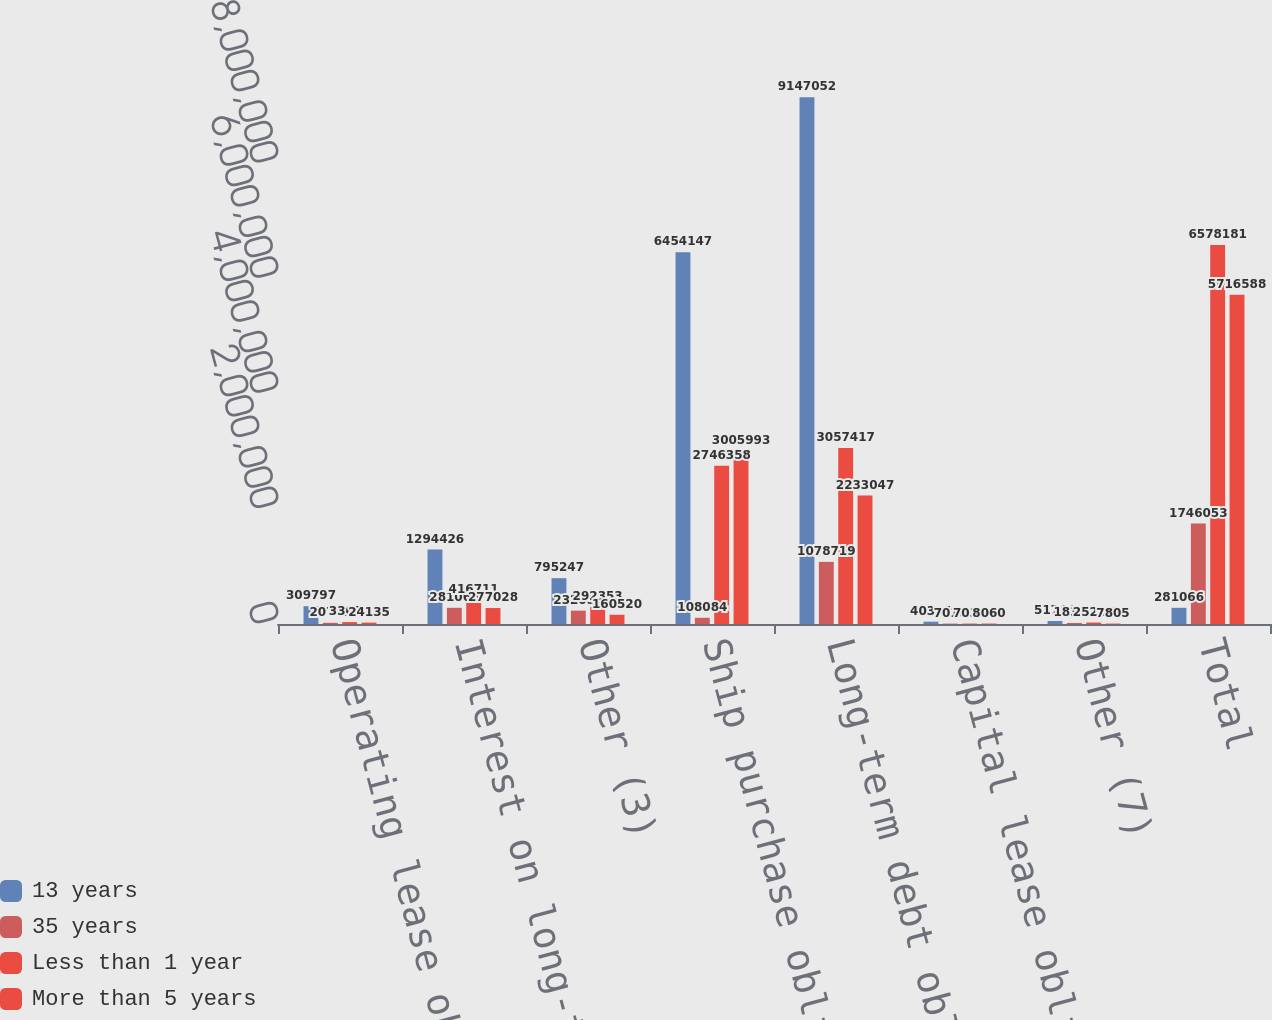Convert chart. <chart><loc_0><loc_0><loc_500><loc_500><stacked_bar_chart><ecel><fcel>Operating lease obligations<fcel>Interest on long-term debt (2)<fcel>Other (3)<fcel>Ship purchase obligations (4)<fcel>Long-term debt obligations (5)<fcel>Capital lease obligations (6)<fcel>Other (7)<fcel>Total<nl><fcel>13 years<fcel>309797<fcel>1.29443e+06<fcel>795247<fcel>6.45415e+06<fcel>9.14705e+06<fcel>40384<fcel>51744<fcel>281066<nl><fcel>35 years<fcel>20749<fcel>281066<fcel>232055<fcel>108084<fcel>1.07872e+06<fcel>7016<fcel>18364<fcel>1.74605e+06<nl><fcel>Less than 1 year<fcel>33025<fcel>416711<fcel>292353<fcel>2.74636e+06<fcel>3.05742e+06<fcel>7031<fcel>25286<fcel>6.57818e+06<nl><fcel>More than 5 years<fcel>24135<fcel>277028<fcel>160520<fcel>3.00599e+06<fcel>2.23305e+06<fcel>8060<fcel>7805<fcel>5.71659e+06<nl></chart> 